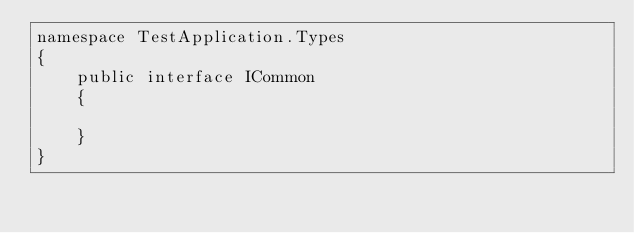<code> <loc_0><loc_0><loc_500><loc_500><_C#_>namespace TestApplication.Types
{
    public interface ICommon
    {
         
    }
}</code> 